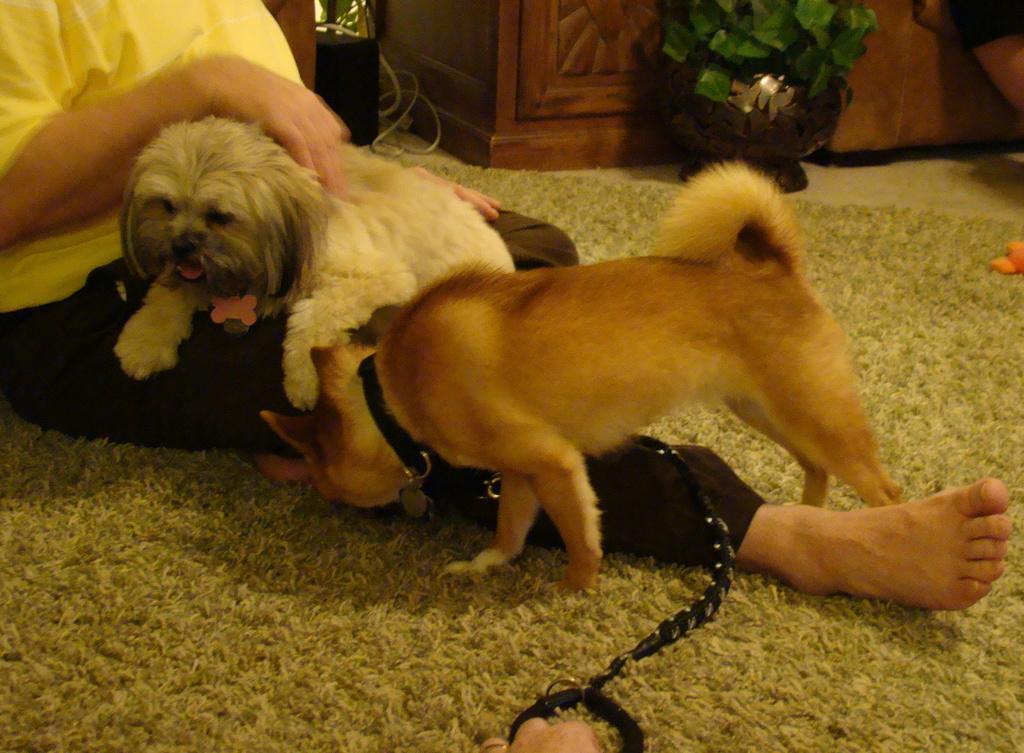Can you describe this image briefly? This picture shows a woman seated on the floor and we see couple of dogs and a string to its neck and we see a carpet on the floor and we see a cupboard and a plant on the side. 